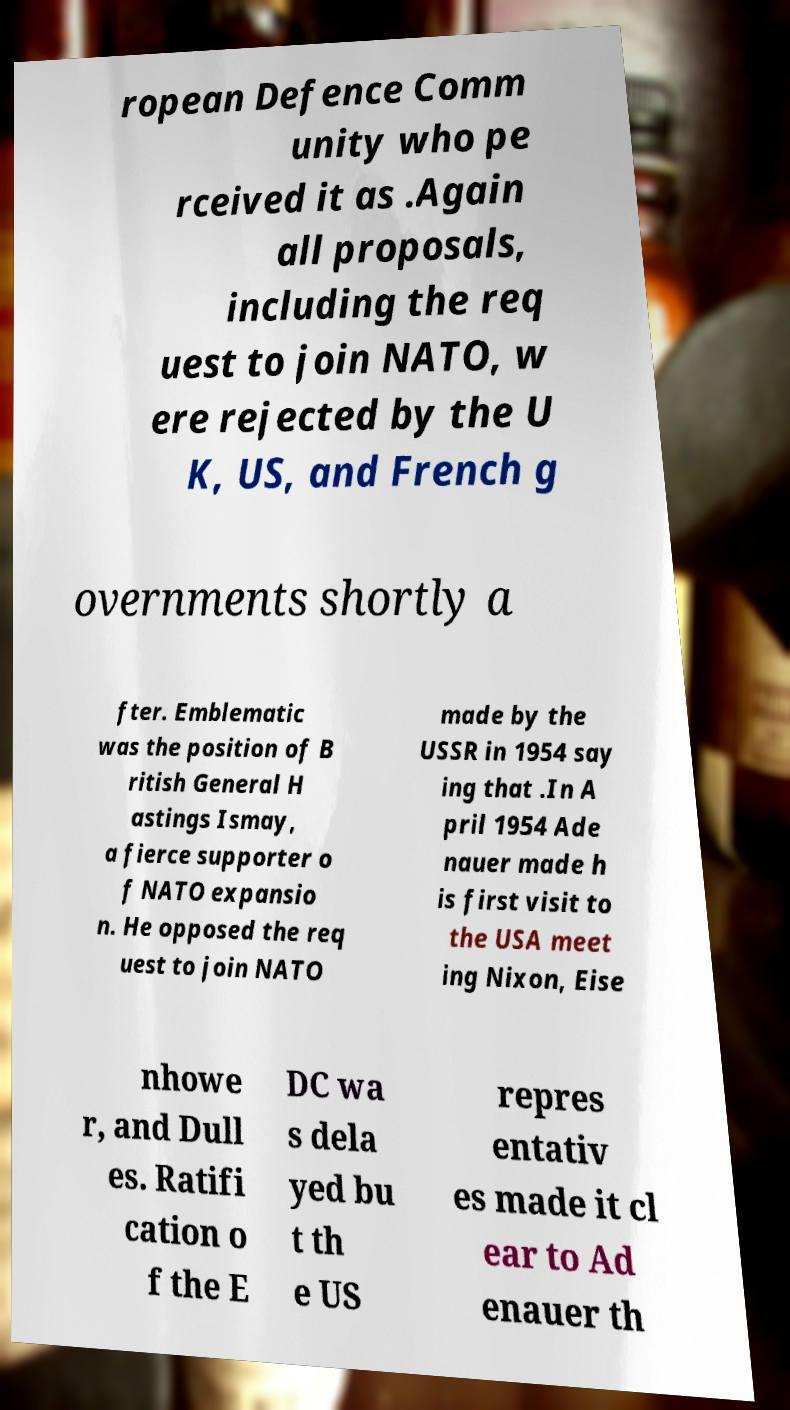For documentation purposes, I need the text within this image transcribed. Could you provide that? ropean Defence Comm unity who pe rceived it as .Again all proposals, including the req uest to join NATO, w ere rejected by the U K, US, and French g overnments shortly a fter. Emblematic was the position of B ritish General H astings Ismay, a fierce supporter o f NATO expansio n. He opposed the req uest to join NATO made by the USSR in 1954 say ing that .In A pril 1954 Ade nauer made h is first visit to the USA meet ing Nixon, Eise nhowe r, and Dull es. Ratifi cation o f the E DC wa s dela yed bu t th e US repres entativ es made it cl ear to Ad enauer th 